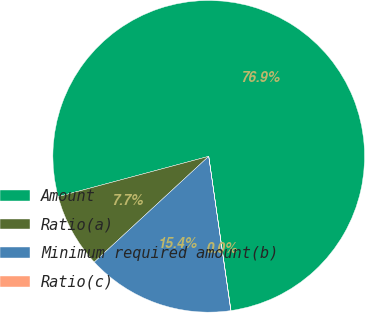Convert chart. <chart><loc_0><loc_0><loc_500><loc_500><pie_chart><fcel>Amount<fcel>Ratio(a)<fcel>Minimum required amount(b)<fcel>Ratio(c)<nl><fcel>76.88%<fcel>7.71%<fcel>15.39%<fcel>0.02%<nl></chart> 